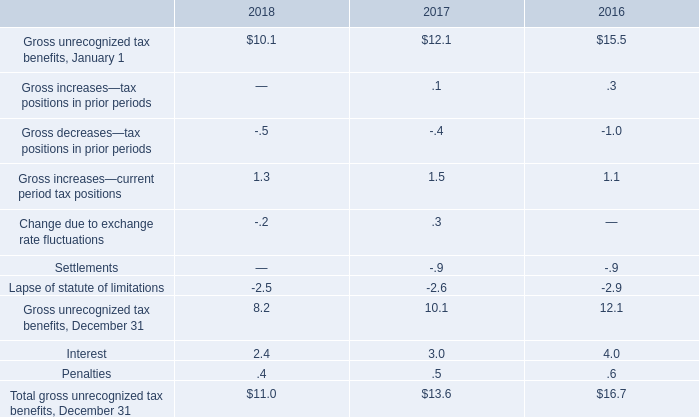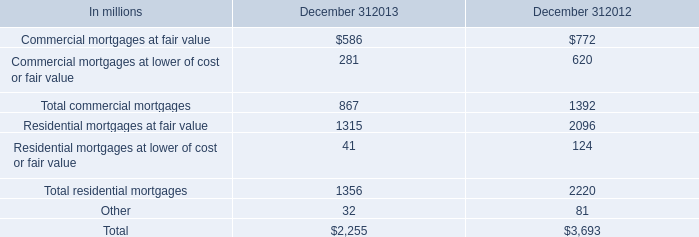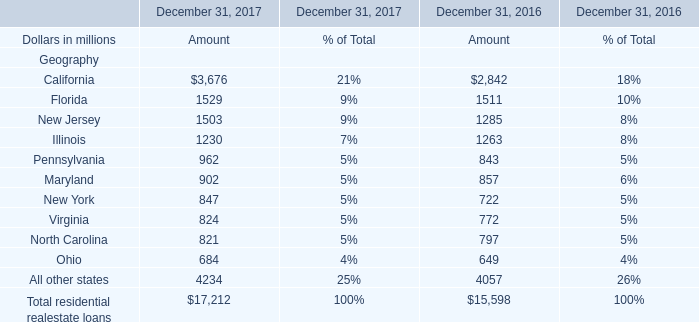What's the sum of All other states of December 31, 2017 Amount, and Residential mortgages at fair value of December 312013 ? 
Computations: (4234.0 + 1315.0)
Answer: 5549.0. 